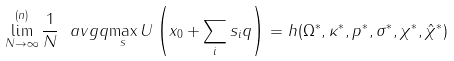<formula> <loc_0><loc_0><loc_500><loc_500>\lim _ { N \to \infty } ^ { ( n ) } \frac { 1 } { N } \ a v g q { \max _ { s } U \left ( x _ { 0 } + \sum _ { i } s _ { i } q \right ) } = h ( \Omega ^ { * } , \kappa ^ { * } , p ^ { * } , \sigma ^ { * } , \chi ^ { * } , \hat { \chi } ^ { * } )</formula> 